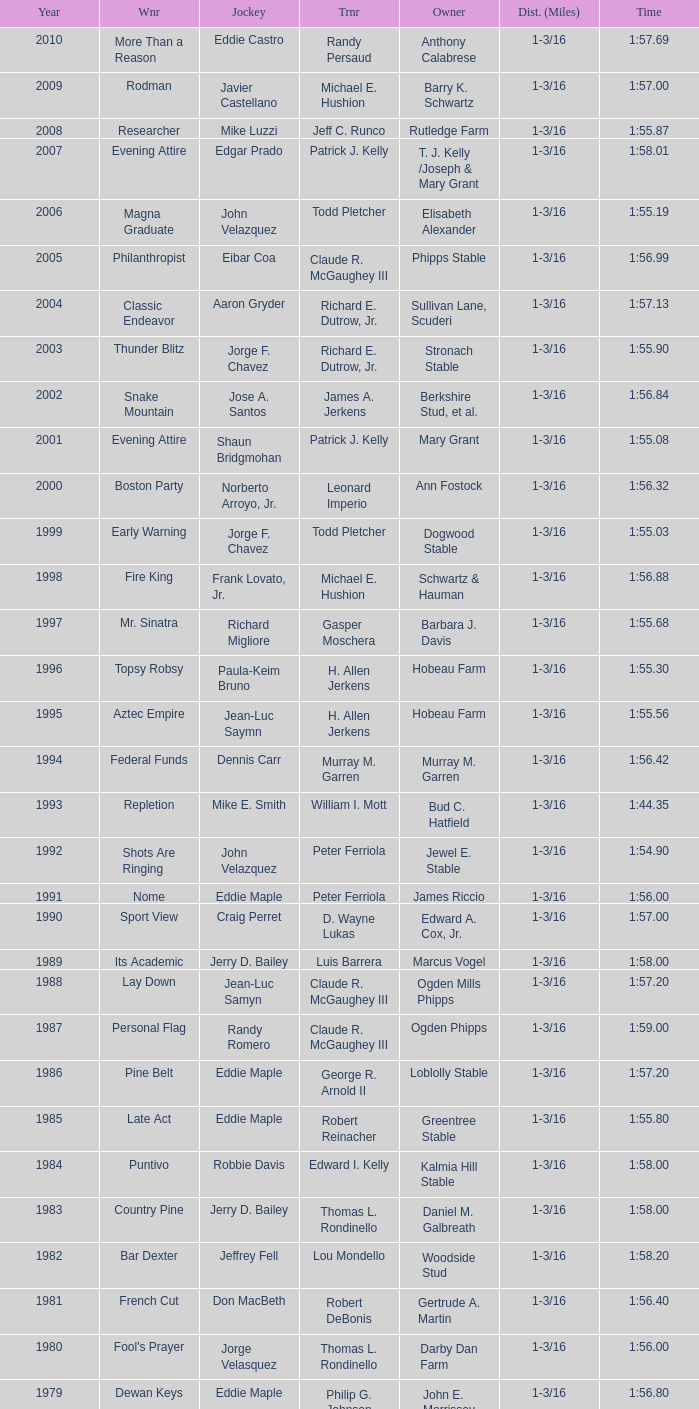What was the time for the winning horse Salford ii? 1:44.20. 